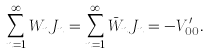<formula> <loc_0><loc_0><loc_500><loc_500>\sum _ { n = 1 } ^ { \infty } W _ { n } J _ { n } = \sum _ { n = 1 } ^ { \infty } \bar { W } _ { n } J _ { n } = - V _ { 0 0 } ^ { \prime } .</formula> 